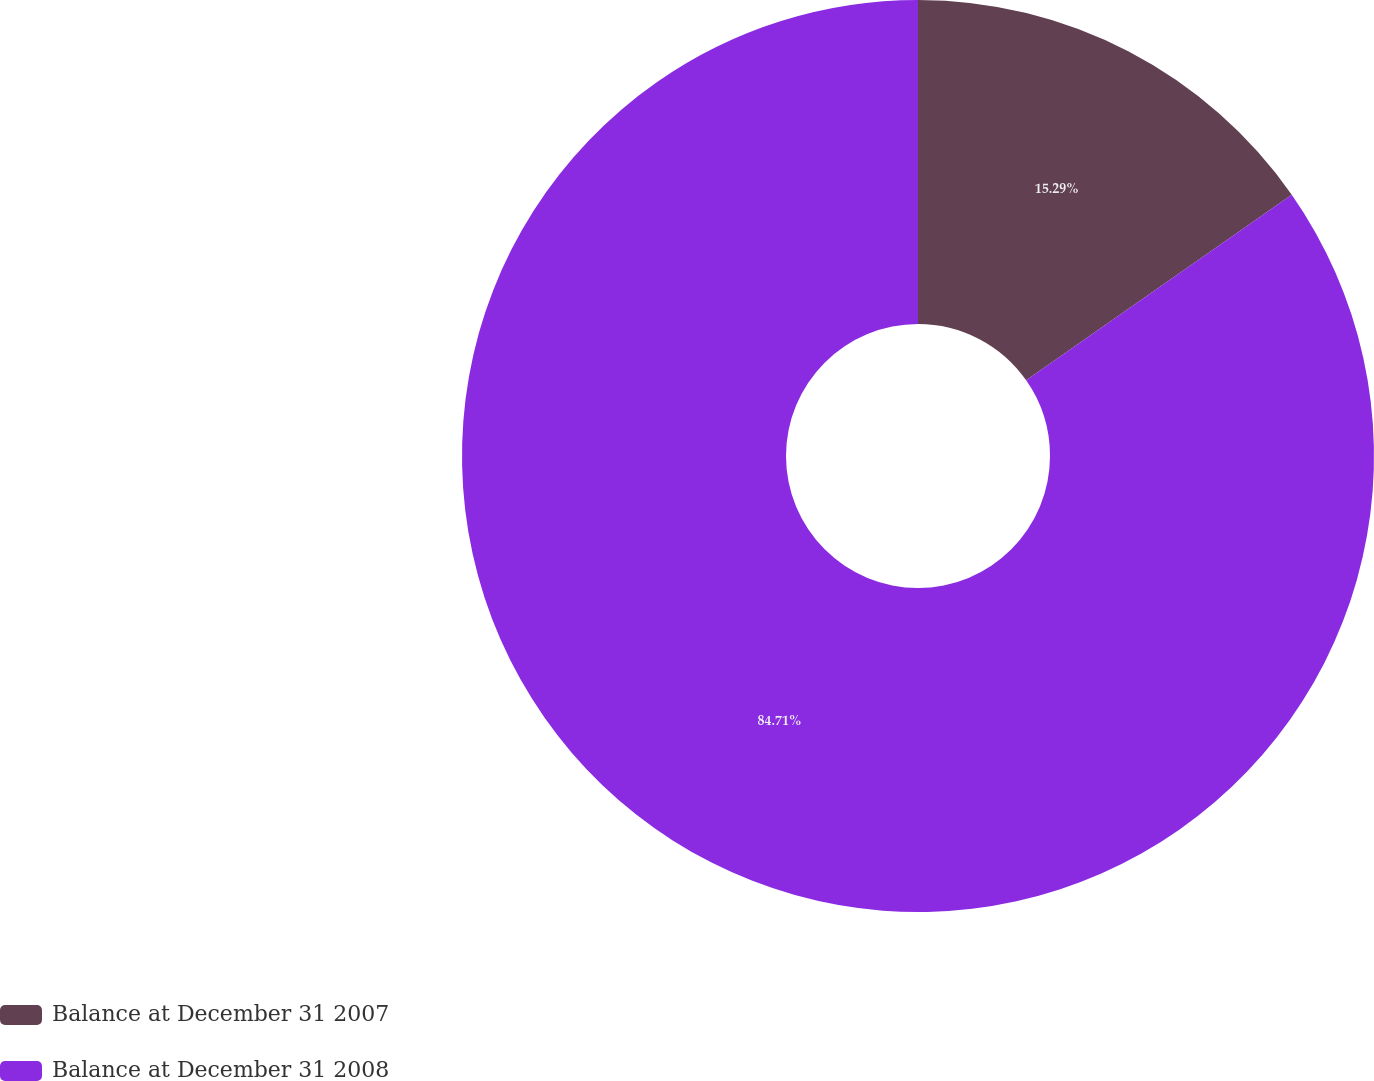Convert chart to OTSL. <chart><loc_0><loc_0><loc_500><loc_500><pie_chart><fcel>Balance at December 31 2007<fcel>Balance at December 31 2008<nl><fcel>15.29%<fcel>84.71%<nl></chart> 